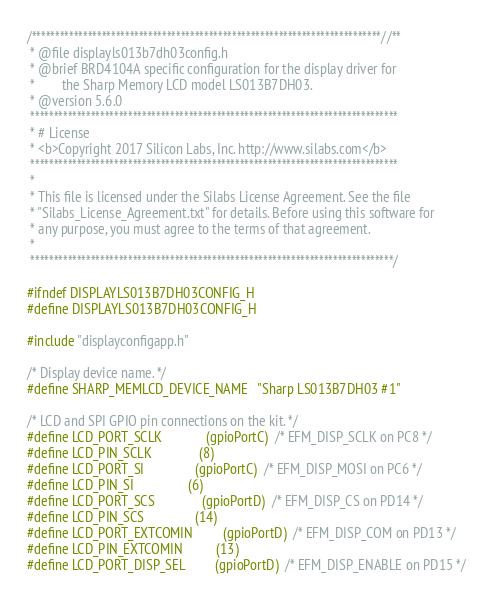<code> <loc_0><loc_0><loc_500><loc_500><_C_>/***************************************************************************//**
 * @file displayls013b7dh03config.h
 * @brief BRD4104A specific configuration for the display driver for
 *        the Sharp Memory LCD model LS013B7DH03.
 * @version 5.6.0
 *******************************************************************************
 * # License
 * <b>Copyright 2017 Silicon Labs, Inc. http://www.silabs.com</b>
 *******************************************************************************
 *
 * This file is licensed under the Silabs License Agreement. See the file
 * "Silabs_License_Agreement.txt" for details. Before using this software for
 * any purpose, you must agree to the terms of that agreement.
 *
 ******************************************************************************/

#ifndef DISPLAYLS013B7DH03CONFIG_H
#define DISPLAYLS013B7DH03CONFIG_H

#include "displayconfigapp.h"

/* Display device name. */
#define SHARP_MEMLCD_DEVICE_NAME   "Sharp LS013B7DH03 #1"

/* LCD and SPI GPIO pin connections on the kit. */
#define LCD_PORT_SCLK             (gpioPortC)  /* EFM_DISP_SCLK on PC8 */
#define LCD_PIN_SCLK              (8)
#define LCD_PORT_SI               (gpioPortC)  /* EFM_DISP_MOSI on PC6 */
#define LCD_PIN_SI                (6)
#define LCD_PORT_SCS              (gpioPortD)  /* EFM_DISP_CS on PD14 */
#define LCD_PIN_SCS               (14)
#define LCD_PORT_EXTCOMIN         (gpioPortD)  /* EFM_DISP_COM on PD13 */
#define LCD_PIN_EXTCOMIN          (13)
#define LCD_PORT_DISP_SEL         (gpioPortD)  /* EFM_DISP_ENABLE on PD15 */</code> 